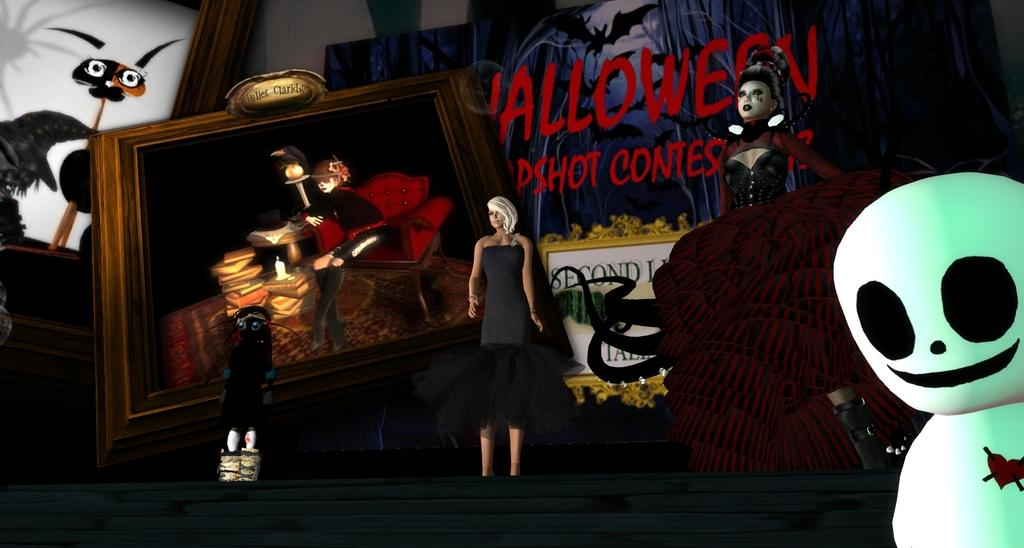What type of image is present in the image? The image contains a graphical image. Can you describe the characters in the image? There are cartoons of persons in the image. Where is the photo frame located in the image? The photo frame is on the left side of the image. What can be seen in the background of the image? There is text visible in the background of the image. How many clocks are present in the image? There are no clocks visible in the image. What type of government is depicted in the image? The image does not depict any government or political entity. 